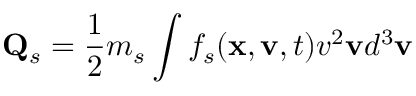<formula> <loc_0><loc_0><loc_500><loc_500>Q _ { s } = \frac { 1 } { 2 } m _ { s } \int f _ { s } ( x , v , t ) v ^ { 2 } v d ^ { 3 } v</formula> 